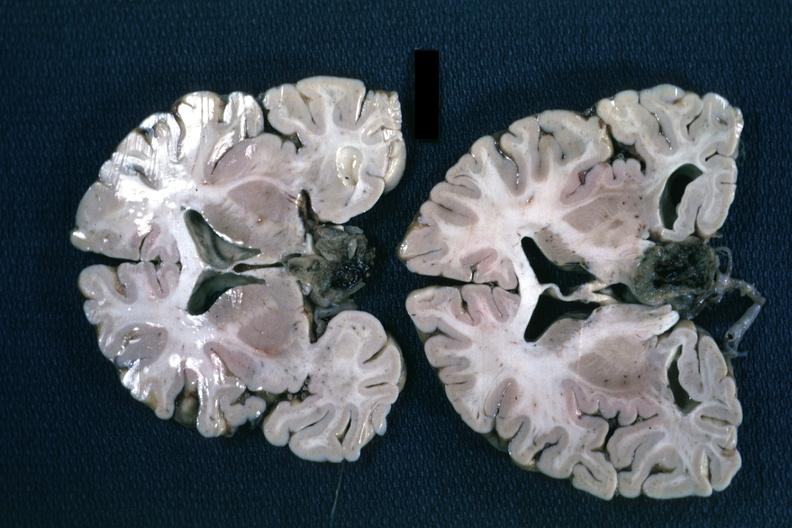what is present?
Answer the question using a single word or phrase. Endocrine 